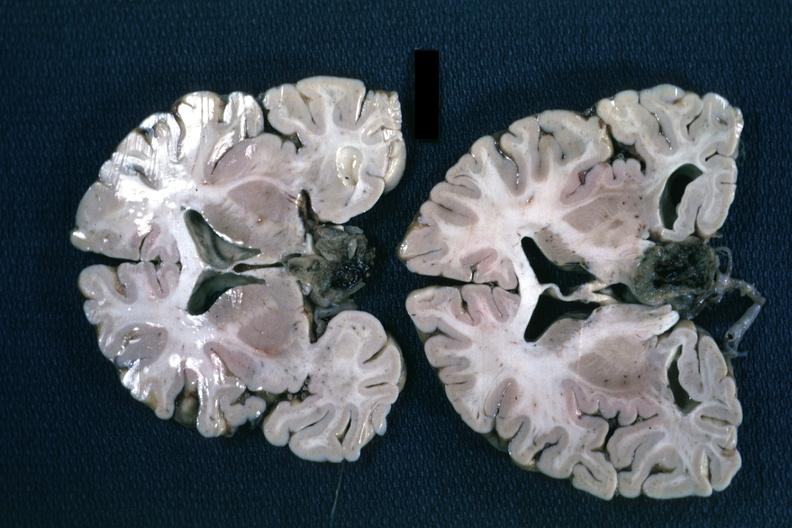what is present?
Answer the question using a single word or phrase. Endocrine 